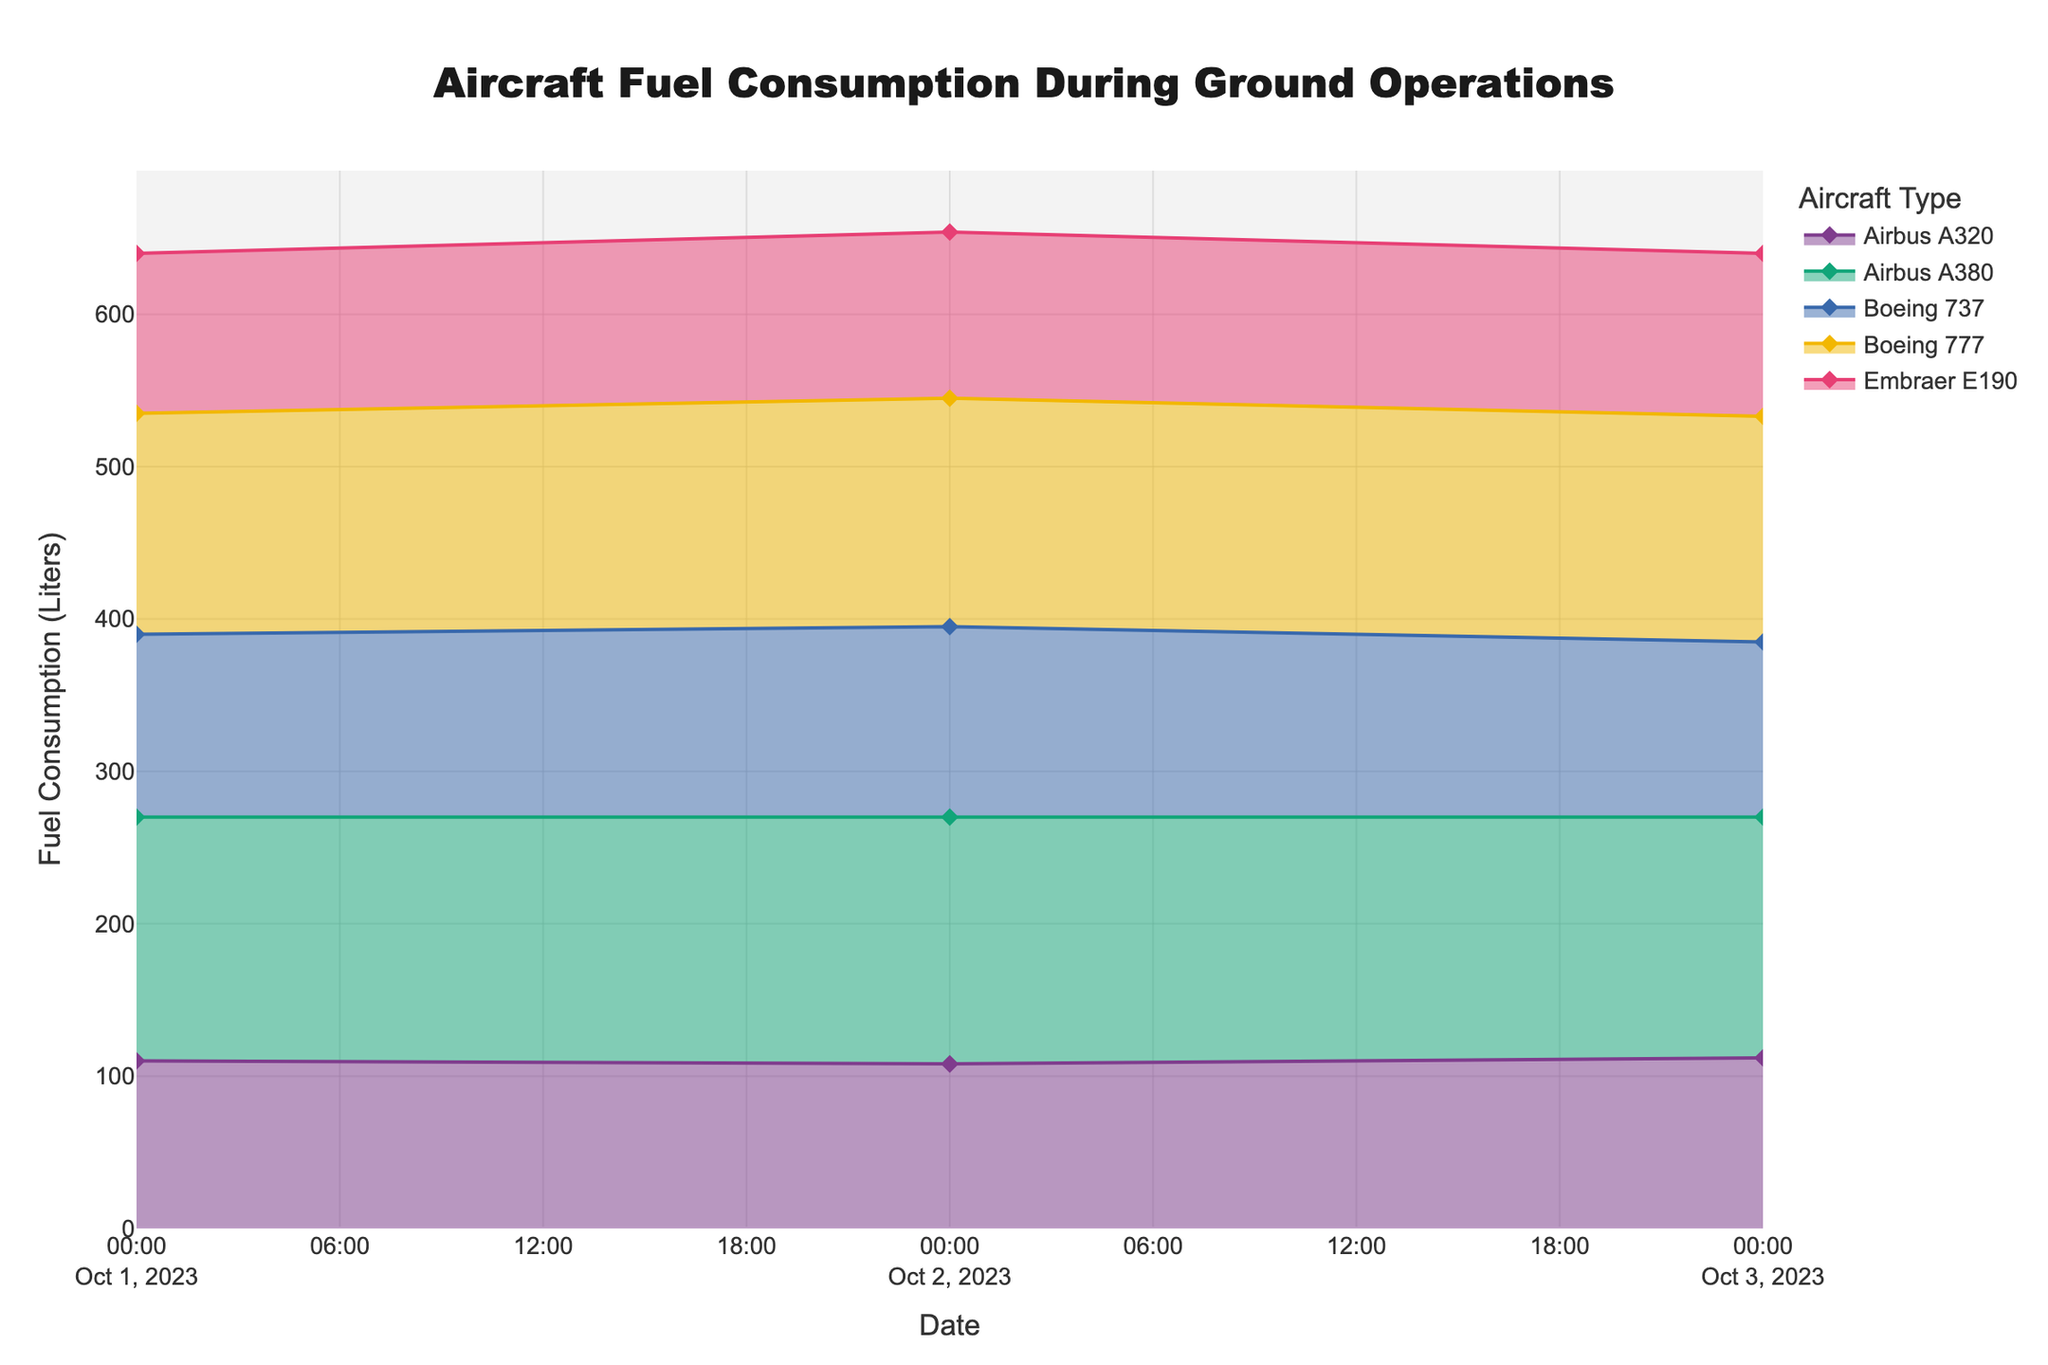What is the title of the figure? The title is usually located at the top of the figure. It provides a brief description of what the figure depicts. In this case, the title is "Aircraft Fuel Consumption During Ground Operations".
Answer: Aircraft Fuel Consumption During Ground Operations What are the axes labels? Axes labels provide information about what each axis represents. The x-axis label of the figure is "Date" and the y-axis label is "Fuel Consumption (Liters)".
Answer: Date and Fuel Consumption (Liters) How many different aircraft types are represented in the figure? Determine the number of unique colors or areas in the figure. Each color corresponds to one aircraft type. There are five different aircraft types represented by different colors in the figure.
Answer: 5 On which date did the Airbus A380 consume the most fuel? Look for the highest point within the area color-coded for Airbus A380. The highest point occurs on the date 2023-10-02 with a fuel consumption of 162 liters.
Answer: 2023-10-02 Which aircraft type has the lowest fuel consumption on October 1st? Identify the lowest point on the y-axis for the date October 1st. The corresponding aircraft type is Embraer E190 with 105 liters.
Answer: Embraer E190 Compare the fuel consumption of Boeing 737 and Airbus A320 on October 2nd. Which aircraft type consumed more fuel? Check the points for both Boeing 737 and Airbus A320 on October 2nd. Boeing 737 consumed 125 liters, whereas Airbus A320 consumed 108 liters, so Boeing 737 consumed more fuel.
Answer: Boeing 737 What is the general trend of fuel consumption for Boeing 777 over the three days? Identify the pattern of the area associated with Boeing 777. The fuel consumption of Boeing 777 is increasing over the three days: from 145 liters on 2023-10-01 to 150 liters on 2023-10-02 and 148 liters on 2023-10-03.
Answer: Increasing Calculate the total fuel consumption for Embraer E190 over the period shown in the figure. Add up all the values of Embraer E190 over the three dates given: 105 + 109 + 107 = 321 liters.
Answer: 321 liters Which aircraft type shows the most variability in fuel consumption over the days displayed? Examine the fluctuation in the heights of the colored areas. Airbus A380 shows the most variability, fluctuating between 160, 162, and 158 liters.
Answer: Airbus A380 What is the average fuel consumption of Boeing 737 over the represented dates? Sum the fuel consumption values for Boeing 737 on all dates and divide by the number of points: (120 + 125 + 115)/3 = 360/3 = 120 liters.
Answer: 120 liters 